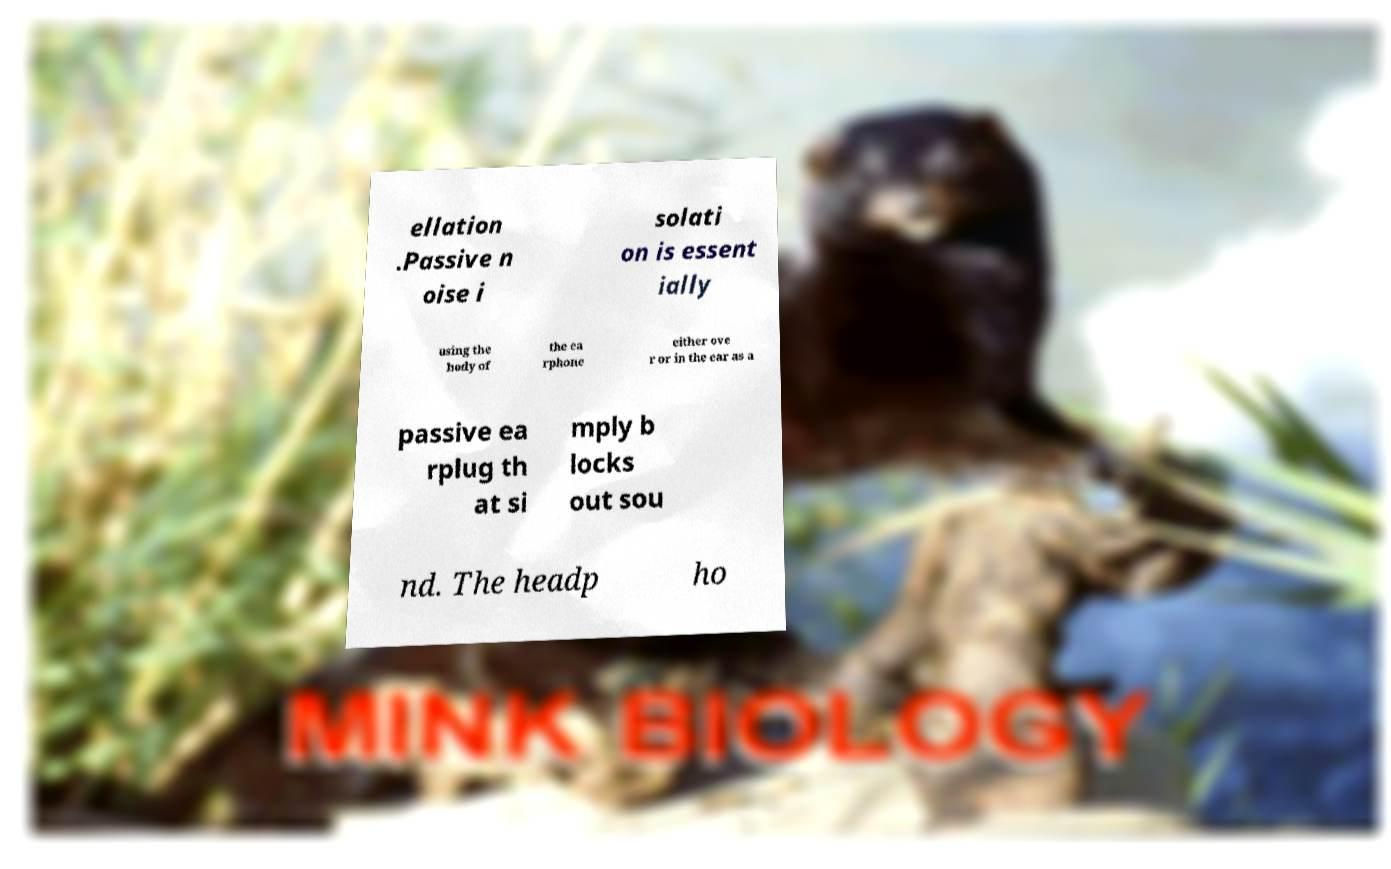I need the written content from this picture converted into text. Can you do that? ellation .Passive n oise i solati on is essent ially using the body of the ea rphone either ove r or in the ear as a passive ea rplug th at si mply b locks out sou nd. The headp ho 